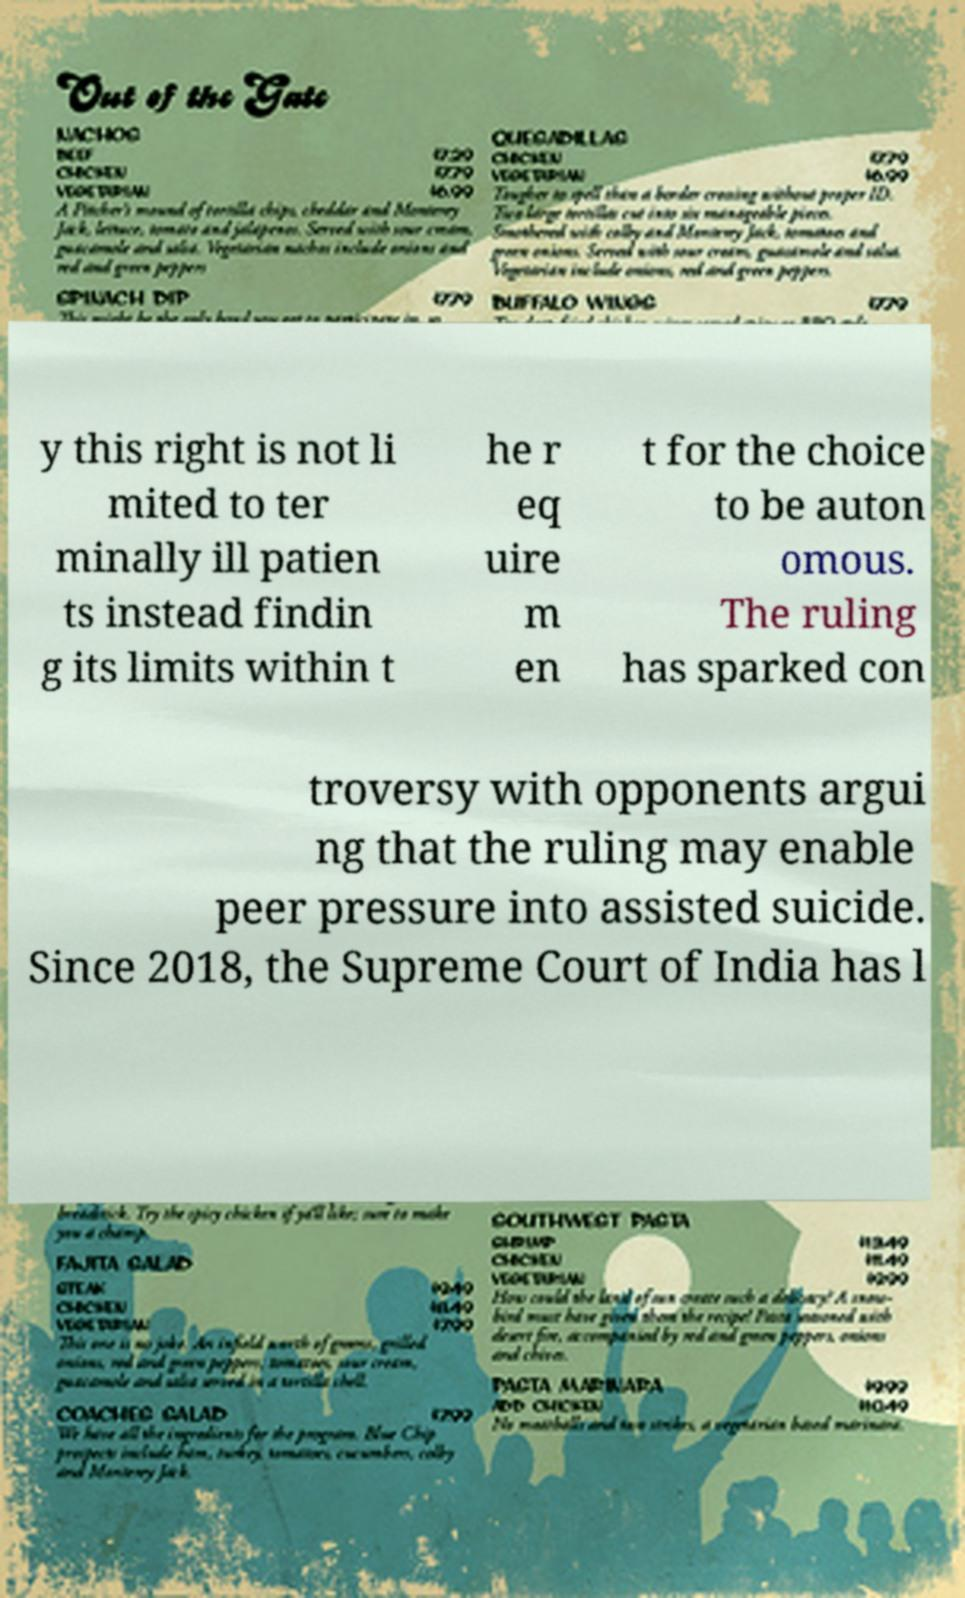What messages or text are displayed in this image? I need them in a readable, typed format. y this right is not li mited to ter minally ill patien ts instead findin g its limits within t he r eq uire m en t for the choice to be auton omous. The ruling has sparked con troversy with opponents argui ng that the ruling may enable peer pressure into assisted suicide. Since 2018, the Supreme Court of India has l 